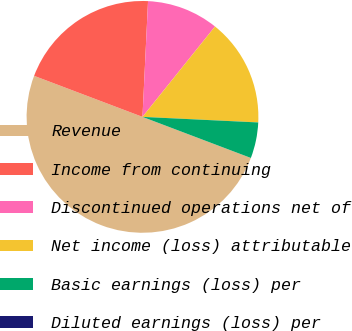Convert chart. <chart><loc_0><loc_0><loc_500><loc_500><pie_chart><fcel>Revenue<fcel>Income from continuing<fcel>Discontinued operations net of<fcel>Net income (loss) attributable<fcel>Basic earnings (loss) per<fcel>Diluted earnings (loss) per<nl><fcel>49.99%<fcel>20.0%<fcel>10.0%<fcel>15.0%<fcel>5.0%<fcel>0.0%<nl></chart> 